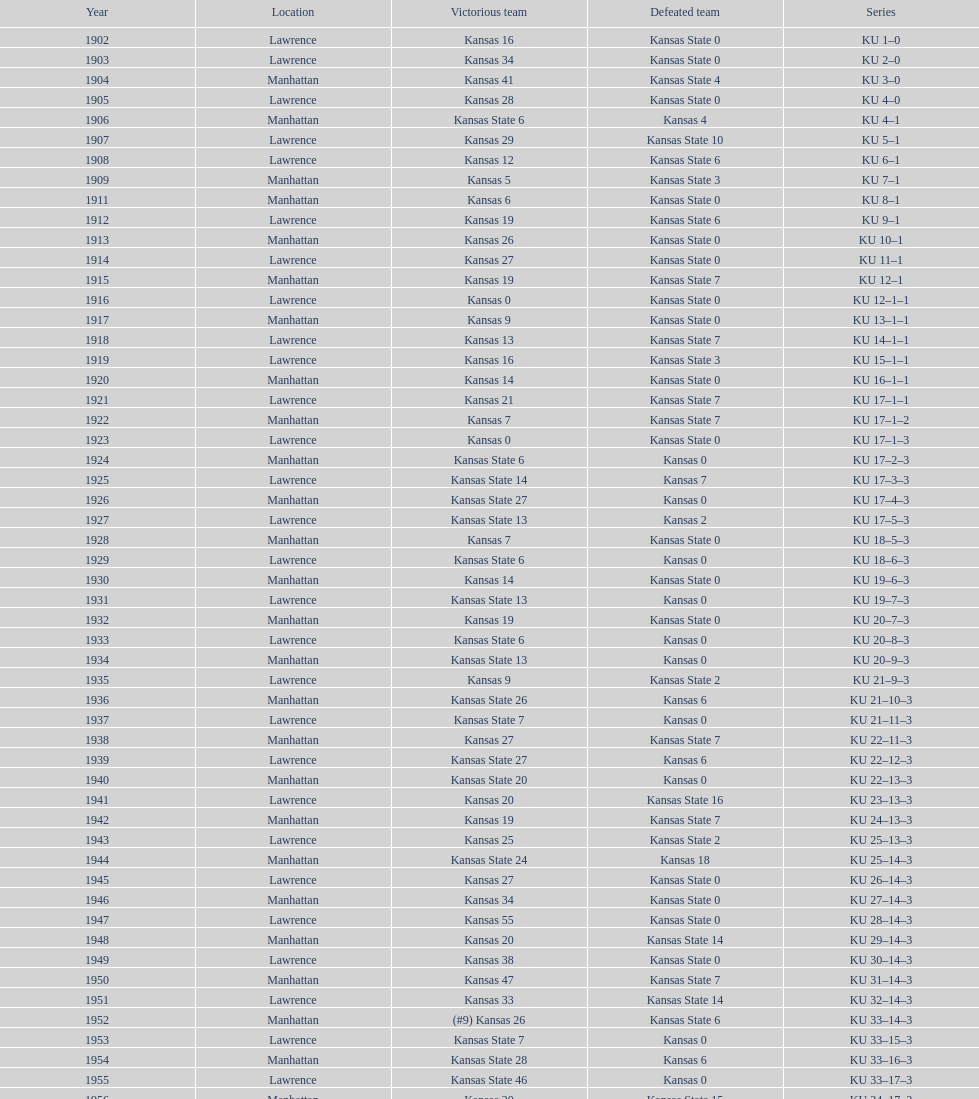When was the last time kansas state lost with 0 points in manhattan? 1964. Could you help me parse every detail presented in this table? {'header': ['Year', 'Location', 'Victorious team', 'Defeated team', 'Series'], 'rows': [['1902', 'Lawrence', 'Kansas 16', 'Kansas State 0', 'KU 1–0'], ['1903', 'Lawrence', 'Kansas 34', 'Kansas State 0', 'KU 2–0'], ['1904', 'Manhattan', 'Kansas 41', 'Kansas State 4', 'KU 3–0'], ['1905', 'Lawrence', 'Kansas 28', 'Kansas State 0', 'KU 4–0'], ['1906', 'Manhattan', 'Kansas State 6', 'Kansas 4', 'KU 4–1'], ['1907', 'Lawrence', 'Kansas 29', 'Kansas State 10', 'KU 5–1'], ['1908', 'Lawrence', 'Kansas 12', 'Kansas State 6', 'KU 6–1'], ['1909', 'Manhattan', 'Kansas 5', 'Kansas State 3', 'KU 7–1'], ['1911', 'Manhattan', 'Kansas 6', 'Kansas State 0', 'KU 8–1'], ['1912', 'Lawrence', 'Kansas 19', 'Kansas State 6', 'KU 9–1'], ['1913', 'Manhattan', 'Kansas 26', 'Kansas State 0', 'KU 10–1'], ['1914', 'Lawrence', 'Kansas 27', 'Kansas State 0', 'KU 11–1'], ['1915', 'Manhattan', 'Kansas 19', 'Kansas State 7', 'KU 12–1'], ['1916', 'Lawrence', 'Kansas 0', 'Kansas State 0', 'KU 12–1–1'], ['1917', 'Manhattan', 'Kansas 9', 'Kansas State 0', 'KU 13–1–1'], ['1918', 'Lawrence', 'Kansas 13', 'Kansas State 7', 'KU 14–1–1'], ['1919', 'Lawrence', 'Kansas 16', 'Kansas State 3', 'KU 15–1–1'], ['1920', 'Manhattan', 'Kansas 14', 'Kansas State 0', 'KU 16–1–1'], ['1921', 'Lawrence', 'Kansas 21', 'Kansas State 7', 'KU 17–1–1'], ['1922', 'Manhattan', 'Kansas 7', 'Kansas State 7', 'KU 17–1–2'], ['1923', 'Lawrence', 'Kansas 0', 'Kansas State 0', 'KU 17–1–3'], ['1924', 'Manhattan', 'Kansas State 6', 'Kansas 0', 'KU 17–2–3'], ['1925', 'Lawrence', 'Kansas State 14', 'Kansas 7', 'KU 17–3–3'], ['1926', 'Manhattan', 'Kansas State 27', 'Kansas 0', 'KU 17–4–3'], ['1927', 'Lawrence', 'Kansas State 13', 'Kansas 2', 'KU 17–5–3'], ['1928', 'Manhattan', 'Kansas 7', 'Kansas State 0', 'KU 18–5–3'], ['1929', 'Lawrence', 'Kansas State 6', 'Kansas 0', 'KU 18–6–3'], ['1930', 'Manhattan', 'Kansas 14', 'Kansas State 0', 'KU 19–6–3'], ['1931', 'Lawrence', 'Kansas State 13', 'Kansas 0', 'KU 19–7–3'], ['1932', 'Manhattan', 'Kansas 19', 'Kansas State 0', 'KU 20–7–3'], ['1933', 'Lawrence', 'Kansas State 6', 'Kansas 0', 'KU 20–8–3'], ['1934', 'Manhattan', 'Kansas State 13', 'Kansas 0', 'KU 20–9–3'], ['1935', 'Lawrence', 'Kansas 9', 'Kansas State 2', 'KU 21–9–3'], ['1936', 'Manhattan', 'Kansas State 26', 'Kansas 6', 'KU 21–10–3'], ['1937', 'Lawrence', 'Kansas State 7', 'Kansas 0', 'KU 21–11–3'], ['1938', 'Manhattan', 'Kansas 27', 'Kansas State 7', 'KU 22–11–3'], ['1939', 'Lawrence', 'Kansas State 27', 'Kansas 6', 'KU 22–12–3'], ['1940', 'Manhattan', 'Kansas State 20', 'Kansas 0', 'KU 22–13–3'], ['1941', 'Lawrence', 'Kansas 20', 'Kansas State 16', 'KU 23–13–3'], ['1942', 'Manhattan', 'Kansas 19', 'Kansas State 7', 'KU 24–13–3'], ['1943', 'Lawrence', 'Kansas 25', 'Kansas State 2', 'KU 25–13–3'], ['1944', 'Manhattan', 'Kansas State 24', 'Kansas 18', 'KU 25–14–3'], ['1945', 'Lawrence', 'Kansas 27', 'Kansas State 0', 'KU 26–14–3'], ['1946', 'Manhattan', 'Kansas 34', 'Kansas State 0', 'KU 27–14–3'], ['1947', 'Lawrence', 'Kansas 55', 'Kansas State 0', 'KU 28–14–3'], ['1948', 'Manhattan', 'Kansas 20', 'Kansas State 14', 'KU 29–14–3'], ['1949', 'Lawrence', 'Kansas 38', 'Kansas State 0', 'KU 30–14–3'], ['1950', 'Manhattan', 'Kansas 47', 'Kansas State 7', 'KU 31–14–3'], ['1951', 'Lawrence', 'Kansas 33', 'Kansas State 14', 'KU 32–14–3'], ['1952', 'Manhattan', '(#9) Kansas 26', 'Kansas State 6', 'KU 33–14–3'], ['1953', 'Lawrence', 'Kansas State 7', 'Kansas 0', 'KU 33–15–3'], ['1954', 'Manhattan', 'Kansas State 28', 'Kansas 6', 'KU 33–16–3'], ['1955', 'Lawrence', 'Kansas State 46', 'Kansas 0', 'KU 33–17–3'], ['1956', 'Manhattan', 'Kansas 20', 'Kansas State 15', 'KU 34–17–3'], ['1957', 'Lawrence', 'Kansas 13', 'Kansas State 7', 'KU 35–17–3'], ['1958', 'Manhattan', 'Kansas 21', 'Kansas State 12', 'KU 36–17–3'], ['1959', 'Lawrence', 'Kansas 33', 'Kansas State 14', 'KU 37–17–3'], ['1960', 'Manhattan', 'Kansas 41', 'Kansas State 0', 'KU 38–17–3'], ['1961', 'Lawrence', 'Kansas 34', 'Kansas State 0', 'KU 39–17–3'], ['1962', 'Manhattan', 'Kansas 38', 'Kansas State 0', 'KU 40–17–3'], ['1963', 'Lawrence', 'Kansas 34', 'Kansas State 0', 'KU 41–17–3'], ['1964', 'Manhattan', 'Kansas 7', 'Kansas State 0', 'KU 42–17–3'], ['1965', 'Lawrence', 'Kansas 34', 'Kansas State 0', 'KU 43–17–3'], ['1966', 'Manhattan', 'Kansas 3', 'Kansas State 3', 'KU 43–17–4'], ['1967', 'Lawrence', 'Kansas 17', 'Kansas State 16', 'KU 44–17–4'], ['1968', 'Manhattan', '(#7) Kansas 38', 'Kansas State 29', 'KU 45–17–4']]} 